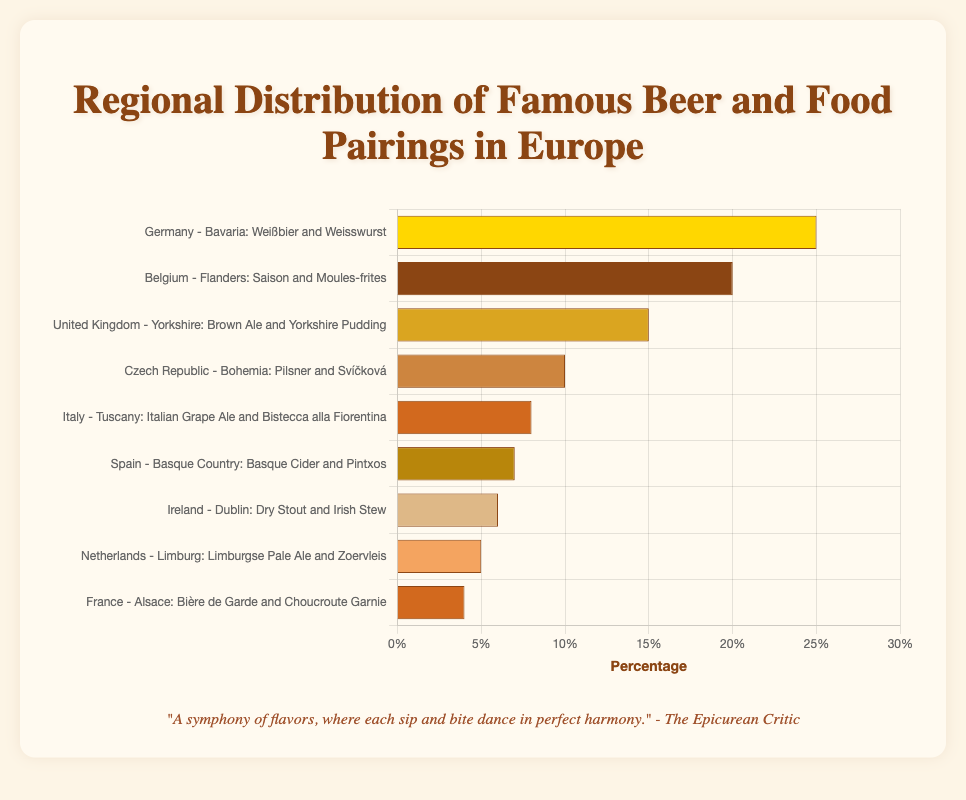What's the most popular beer and food pairing and what is its percentage? The most popular pairing is the one with the highest percentage value. According to the data, Weißbier and Weisswurst from Germany - Bavaria have the highest percentage at 25%.
Answer: Weißbier and Weisswurst, 25% What's the difference in percentage between the most and least popular beer and food pairings? The most popular pairing has a percentage of 25% and the least popular has a percentage of 4%. The difference can be calculated as 25% - 4% = 21%.
Answer: 21% Which regions have a beer and food pairing percentage above 10%? The regions with beer and food pairings above 10% are those whose percentage values are above 10%. They include Germany - Bavaria (25%), Belgium - Flanders (20%), and United Kingdom - Yorkshire (15%).
Answer: Germany - Bavaria, Belgium - Flanders, and United Kingdom - Yorkshire What's the combined percentage of the beer and food pairings from Italy, Spain, and Ireland? Adding the percentages for Italy, Spain, and Ireland gives us 8% (Italy) + 7% (Spain) + 6% (Ireland) = 21%.
Answer: 21% Which beer and food pairing has a visual attribute of being the third longest bar in the chart? The third longest bar corresponds to the third highest percentage in the data set. According to the data, the third highest percentage is 15% associated with Brown Ale and Yorkshire Pudding from the United Kingdom - Yorkshire.
Answer: Brown Ale and Yorkshire Pudding What is the average percentage of beer and food pairings from the top three popular regions? The top three regions based on popularity have percentages of 25%, 20%, and 15%. The average is calculated as (25% + 20% + 15%) / 3 = 60% / 3 = 20%.
Answer: 20% By how much does the percentage of Belgium's pairing exceed the sum of Netherlands and France's pairings? The pairing percentage for Belgium is 20%. The combined percentage for Netherlands (5%) and France (4%) is 5% + 4% = 9%. The excess amount is 20% - 9% = 11%.
Answer: 11% Which region's pairing has a brighest yellowish bar color associated with it? In the visual representation, the color bright yellowish (#FFD700) is associated with the region "Germany - Bavaria: Weißbier and Weisswurst".
Answer: Germany - Bavaria: Weißbier and Weisswurst 